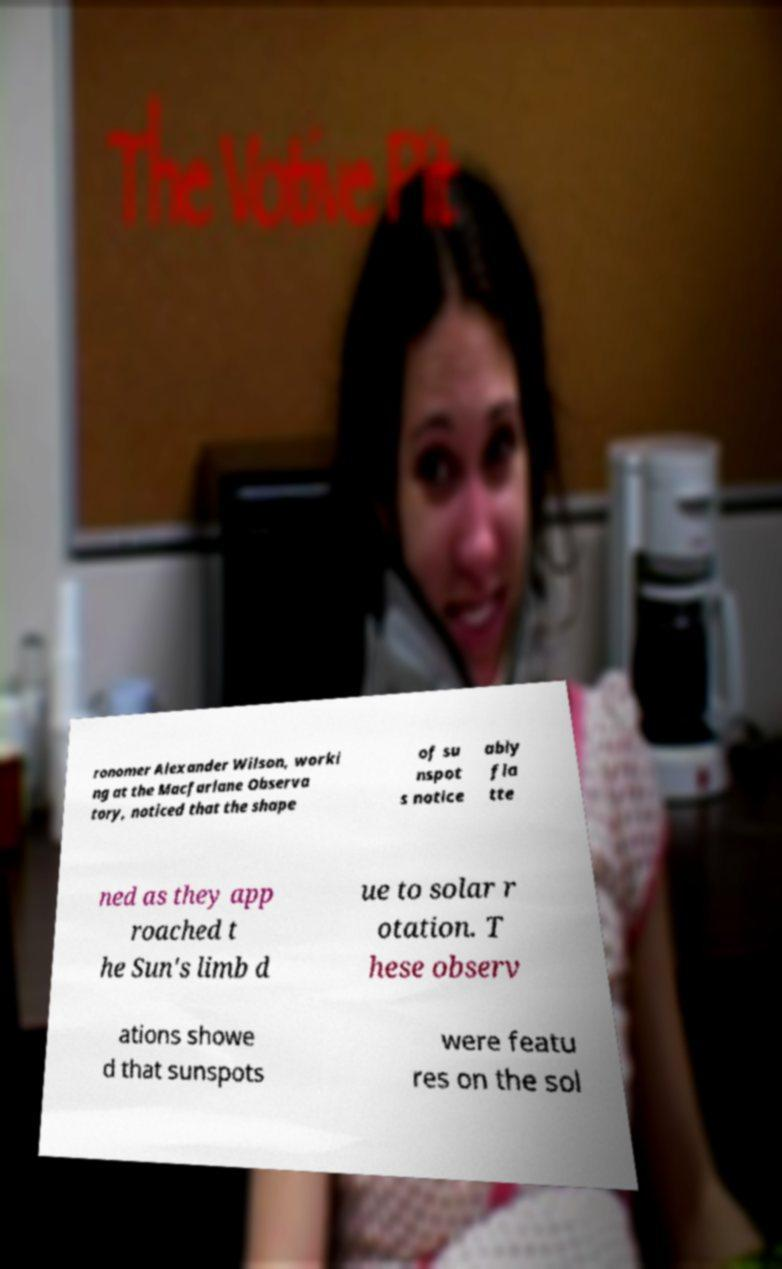I need the written content from this picture converted into text. Can you do that? ronomer Alexander Wilson, worki ng at the Macfarlane Observa tory, noticed that the shape of su nspot s notice ably fla tte ned as they app roached t he Sun's limb d ue to solar r otation. T hese observ ations showe d that sunspots were featu res on the sol 